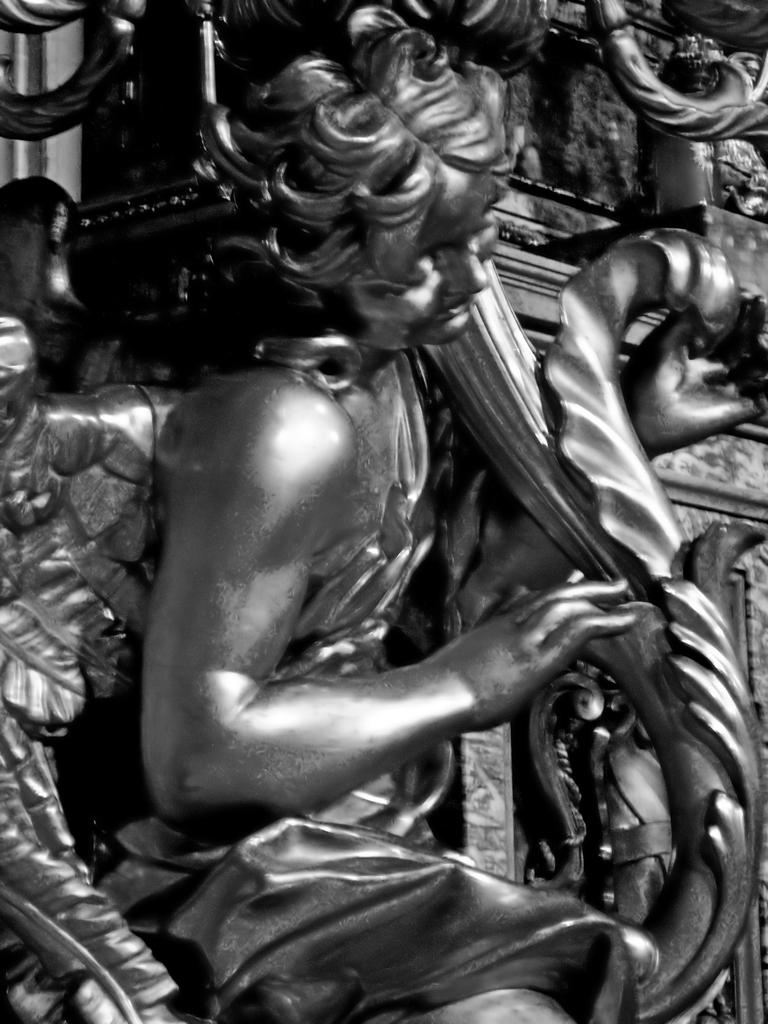What is the main subject of the image? There is a statue in the image. What is the statue depicting? The statue is of a person. What is the person in the statue holding? The person is holding an object. What type of rhythm can be heard coming from the statue in the image? There is no sound or rhythm associated with the statue in the image. 